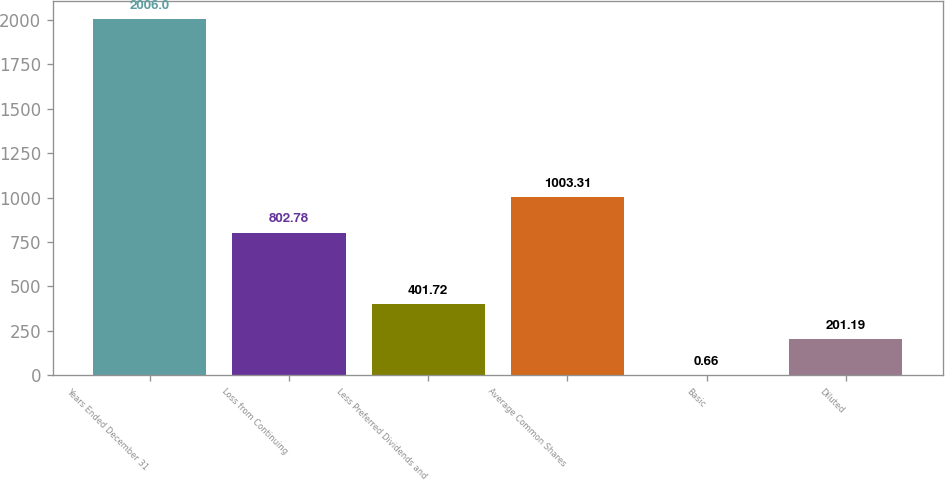Convert chart. <chart><loc_0><loc_0><loc_500><loc_500><bar_chart><fcel>Years Ended December 31<fcel>Loss from Continuing<fcel>Less Preferred Dividends and<fcel>Average Common Shares<fcel>Basic<fcel>Diluted<nl><fcel>2006<fcel>802.78<fcel>401.72<fcel>1003.31<fcel>0.66<fcel>201.19<nl></chart> 